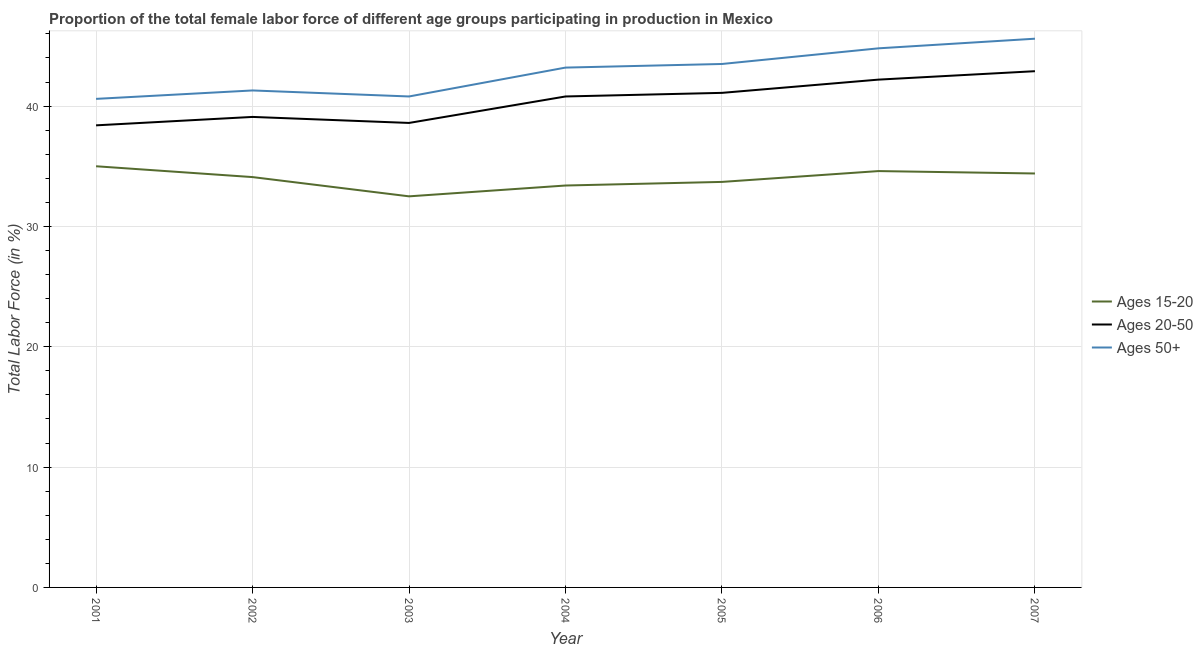What is the percentage of female labor force above age 50 in 2003?
Provide a short and direct response. 40.8. Across all years, what is the minimum percentage of female labor force above age 50?
Offer a very short reply. 40.6. What is the total percentage of female labor force within the age group 20-50 in the graph?
Your answer should be very brief. 283.1. What is the difference between the percentage of female labor force within the age group 15-20 in 2004 and that in 2007?
Keep it short and to the point. -1. What is the difference between the percentage of female labor force within the age group 15-20 in 2007 and the percentage of female labor force within the age group 20-50 in 2004?
Provide a short and direct response. -6.4. What is the average percentage of female labor force above age 50 per year?
Offer a terse response. 42.83. In the year 2001, what is the difference between the percentage of female labor force within the age group 20-50 and percentage of female labor force above age 50?
Offer a very short reply. -2.2. In how many years, is the percentage of female labor force within the age group 15-20 greater than 4 %?
Give a very brief answer. 7. What is the ratio of the percentage of female labor force above age 50 in 2006 to that in 2007?
Give a very brief answer. 0.98. Is the difference between the percentage of female labor force within the age group 20-50 in 2003 and 2006 greater than the difference between the percentage of female labor force within the age group 15-20 in 2003 and 2006?
Your answer should be very brief. No. What is the difference between the highest and the second highest percentage of female labor force above age 50?
Your answer should be very brief. 0.8. In how many years, is the percentage of female labor force within the age group 15-20 greater than the average percentage of female labor force within the age group 15-20 taken over all years?
Offer a very short reply. 4. Is the sum of the percentage of female labor force above age 50 in 2005 and 2006 greater than the maximum percentage of female labor force within the age group 20-50 across all years?
Offer a very short reply. Yes. Is it the case that in every year, the sum of the percentage of female labor force within the age group 15-20 and percentage of female labor force within the age group 20-50 is greater than the percentage of female labor force above age 50?
Make the answer very short. Yes. Does the percentage of female labor force within the age group 15-20 monotonically increase over the years?
Provide a succinct answer. No. How many years are there in the graph?
Give a very brief answer. 7. Are the values on the major ticks of Y-axis written in scientific E-notation?
Your answer should be compact. No. Where does the legend appear in the graph?
Ensure brevity in your answer.  Center right. What is the title of the graph?
Keep it short and to the point. Proportion of the total female labor force of different age groups participating in production in Mexico. Does "Other sectors" appear as one of the legend labels in the graph?
Offer a terse response. No. What is the Total Labor Force (in %) in Ages 15-20 in 2001?
Provide a short and direct response. 35. What is the Total Labor Force (in %) of Ages 20-50 in 2001?
Make the answer very short. 38.4. What is the Total Labor Force (in %) in Ages 50+ in 2001?
Provide a succinct answer. 40.6. What is the Total Labor Force (in %) in Ages 15-20 in 2002?
Ensure brevity in your answer.  34.1. What is the Total Labor Force (in %) of Ages 20-50 in 2002?
Keep it short and to the point. 39.1. What is the Total Labor Force (in %) of Ages 50+ in 2002?
Ensure brevity in your answer.  41.3. What is the Total Labor Force (in %) of Ages 15-20 in 2003?
Give a very brief answer. 32.5. What is the Total Labor Force (in %) in Ages 20-50 in 2003?
Provide a succinct answer. 38.6. What is the Total Labor Force (in %) of Ages 50+ in 2003?
Your answer should be compact. 40.8. What is the Total Labor Force (in %) of Ages 15-20 in 2004?
Ensure brevity in your answer.  33.4. What is the Total Labor Force (in %) in Ages 20-50 in 2004?
Offer a terse response. 40.8. What is the Total Labor Force (in %) in Ages 50+ in 2004?
Give a very brief answer. 43.2. What is the Total Labor Force (in %) in Ages 15-20 in 2005?
Your answer should be compact. 33.7. What is the Total Labor Force (in %) of Ages 20-50 in 2005?
Provide a short and direct response. 41.1. What is the Total Labor Force (in %) of Ages 50+ in 2005?
Your answer should be very brief. 43.5. What is the Total Labor Force (in %) of Ages 15-20 in 2006?
Ensure brevity in your answer.  34.6. What is the Total Labor Force (in %) in Ages 20-50 in 2006?
Provide a succinct answer. 42.2. What is the Total Labor Force (in %) in Ages 50+ in 2006?
Give a very brief answer. 44.8. What is the Total Labor Force (in %) of Ages 15-20 in 2007?
Provide a short and direct response. 34.4. What is the Total Labor Force (in %) of Ages 20-50 in 2007?
Your response must be concise. 42.9. What is the Total Labor Force (in %) in Ages 50+ in 2007?
Ensure brevity in your answer.  45.6. Across all years, what is the maximum Total Labor Force (in %) of Ages 15-20?
Keep it short and to the point. 35. Across all years, what is the maximum Total Labor Force (in %) in Ages 20-50?
Your answer should be compact. 42.9. Across all years, what is the maximum Total Labor Force (in %) in Ages 50+?
Offer a terse response. 45.6. Across all years, what is the minimum Total Labor Force (in %) of Ages 15-20?
Keep it short and to the point. 32.5. Across all years, what is the minimum Total Labor Force (in %) of Ages 20-50?
Provide a short and direct response. 38.4. Across all years, what is the minimum Total Labor Force (in %) of Ages 50+?
Your response must be concise. 40.6. What is the total Total Labor Force (in %) of Ages 15-20 in the graph?
Your response must be concise. 237.7. What is the total Total Labor Force (in %) of Ages 20-50 in the graph?
Your answer should be very brief. 283.1. What is the total Total Labor Force (in %) in Ages 50+ in the graph?
Keep it short and to the point. 299.8. What is the difference between the Total Labor Force (in %) in Ages 20-50 in 2001 and that in 2002?
Provide a succinct answer. -0.7. What is the difference between the Total Labor Force (in %) of Ages 50+ in 2001 and that in 2002?
Offer a terse response. -0.7. What is the difference between the Total Labor Force (in %) in Ages 20-50 in 2001 and that in 2003?
Offer a very short reply. -0.2. What is the difference between the Total Labor Force (in %) in Ages 15-20 in 2001 and that in 2004?
Give a very brief answer. 1.6. What is the difference between the Total Labor Force (in %) in Ages 20-50 in 2001 and that in 2004?
Provide a short and direct response. -2.4. What is the difference between the Total Labor Force (in %) in Ages 50+ in 2001 and that in 2004?
Make the answer very short. -2.6. What is the difference between the Total Labor Force (in %) in Ages 15-20 in 2001 and that in 2005?
Your answer should be compact. 1.3. What is the difference between the Total Labor Force (in %) in Ages 50+ in 2001 and that in 2007?
Ensure brevity in your answer.  -5. What is the difference between the Total Labor Force (in %) of Ages 50+ in 2002 and that in 2004?
Give a very brief answer. -1.9. What is the difference between the Total Labor Force (in %) of Ages 20-50 in 2002 and that in 2005?
Give a very brief answer. -2. What is the difference between the Total Labor Force (in %) of Ages 50+ in 2002 and that in 2005?
Your response must be concise. -2.2. What is the difference between the Total Labor Force (in %) of Ages 50+ in 2002 and that in 2007?
Offer a terse response. -4.3. What is the difference between the Total Labor Force (in %) in Ages 50+ in 2003 and that in 2004?
Your answer should be compact. -2.4. What is the difference between the Total Labor Force (in %) of Ages 15-20 in 2003 and that in 2005?
Offer a terse response. -1.2. What is the difference between the Total Labor Force (in %) of Ages 20-50 in 2003 and that in 2006?
Keep it short and to the point. -3.6. What is the difference between the Total Labor Force (in %) of Ages 50+ in 2004 and that in 2005?
Provide a short and direct response. -0.3. What is the difference between the Total Labor Force (in %) in Ages 15-20 in 2004 and that in 2006?
Offer a terse response. -1.2. What is the difference between the Total Labor Force (in %) of Ages 50+ in 2004 and that in 2007?
Give a very brief answer. -2.4. What is the difference between the Total Labor Force (in %) of Ages 50+ in 2005 and that in 2006?
Provide a short and direct response. -1.3. What is the difference between the Total Labor Force (in %) in Ages 20-50 in 2005 and that in 2007?
Offer a very short reply. -1.8. What is the difference between the Total Labor Force (in %) in Ages 50+ in 2005 and that in 2007?
Provide a short and direct response. -2.1. What is the difference between the Total Labor Force (in %) in Ages 20-50 in 2006 and that in 2007?
Provide a succinct answer. -0.7. What is the difference between the Total Labor Force (in %) of Ages 15-20 in 2001 and the Total Labor Force (in %) of Ages 50+ in 2002?
Provide a succinct answer. -6.3. What is the difference between the Total Labor Force (in %) of Ages 20-50 in 2001 and the Total Labor Force (in %) of Ages 50+ in 2003?
Keep it short and to the point. -2.4. What is the difference between the Total Labor Force (in %) of Ages 15-20 in 2001 and the Total Labor Force (in %) of Ages 20-50 in 2004?
Your response must be concise. -5.8. What is the difference between the Total Labor Force (in %) of Ages 20-50 in 2001 and the Total Labor Force (in %) of Ages 50+ in 2004?
Give a very brief answer. -4.8. What is the difference between the Total Labor Force (in %) in Ages 15-20 in 2001 and the Total Labor Force (in %) in Ages 20-50 in 2005?
Keep it short and to the point. -6.1. What is the difference between the Total Labor Force (in %) in Ages 20-50 in 2001 and the Total Labor Force (in %) in Ages 50+ in 2005?
Your answer should be very brief. -5.1. What is the difference between the Total Labor Force (in %) of Ages 15-20 in 2001 and the Total Labor Force (in %) of Ages 20-50 in 2006?
Offer a very short reply. -7.2. What is the difference between the Total Labor Force (in %) in Ages 15-20 in 2001 and the Total Labor Force (in %) in Ages 50+ in 2006?
Your answer should be very brief. -9.8. What is the difference between the Total Labor Force (in %) in Ages 20-50 in 2001 and the Total Labor Force (in %) in Ages 50+ in 2006?
Provide a succinct answer. -6.4. What is the difference between the Total Labor Force (in %) in Ages 15-20 in 2001 and the Total Labor Force (in %) in Ages 50+ in 2007?
Your answer should be very brief. -10.6. What is the difference between the Total Labor Force (in %) of Ages 15-20 in 2002 and the Total Labor Force (in %) of Ages 50+ in 2003?
Offer a very short reply. -6.7. What is the difference between the Total Labor Force (in %) in Ages 15-20 in 2002 and the Total Labor Force (in %) in Ages 20-50 in 2004?
Your answer should be compact. -6.7. What is the difference between the Total Labor Force (in %) in Ages 15-20 in 2002 and the Total Labor Force (in %) in Ages 20-50 in 2005?
Your answer should be compact. -7. What is the difference between the Total Labor Force (in %) in Ages 20-50 in 2002 and the Total Labor Force (in %) in Ages 50+ in 2005?
Your response must be concise. -4.4. What is the difference between the Total Labor Force (in %) of Ages 15-20 in 2002 and the Total Labor Force (in %) of Ages 50+ in 2006?
Your answer should be very brief. -10.7. What is the difference between the Total Labor Force (in %) of Ages 15-20 in 2003 and the Total Labor Force (in %) of Ages 20-50 in 2004?
Offer a terse response. -8.3. What is the difference between the Total Labor Force (in %) of Ages 15-20 in 2003 and the Total Labor Force (in %) of Ages 50+ in 2005?
Offer a very short reply. -11. What is the difference between the Total Labor Force (in %) of Ages 15-20 in 2003 and the Total Labor Force (in %) of Ages 50+ in 2006?
Your response must be concise. -12.3. What is the difference between the Total Labor Force (in %) in Ages 15-20 in 2003 and the Total Labor Force (in %) in Ages 20-50 in 2007?
Your answer should be compact. -10.4. What is the difference between the Total Labor Force (in %) in Ages 15-20 in 2003 and the Total Labor Force (in %) in Ages 50+ in 2007?
Give a very brief answer. -13.1. What is the difference between the Total Labor Force (in %) of Ages 20-50 in 2003 and the Total Labor Force (in %) of Ages 50+ in 2007?
Your response must be concise. -7. What is the difference between the Total Labor Force (in %) of Ages 15-20 in 2004 and the Total Labor Force (in %) of Ages 20-50 in 2005?
Keep it short and to the point. -7.7. What is the difference between the Total Labor Force (in %) of Ages 15-20 in 2004 and the Total Labor Force (in %) of Ages 20-50 in 2006?
Keep it short and to the point. -8.8. What is the difference between the Total Labor Force (in %) of Ages 20-50 in 2004 and the Total Labor Force (in %) of Ages 50+ in 2006?
Offer a terse response. -4. What is the difference between the Total Labor Force (in %) of Ages 15-20 in 2004 and the Total Labor Force (in %) of Ages 50+ in 2007?
Give a very brief answer. -12.2. What is the difference between the Total Labor Force (in %) of Ages 20-50 in 2004 and the Total Labor Force (in %) of Ages 50+ in 2007?
Provide a succinct answer. -4.8. What is the difference between the Total Labor Force (in %) in Ages 15-20 in 2005 and the Total Labor Force (in %) in Ages 50+ in 2006?
Give a very brief answer. -11.1. What is the difference between the Total Labor Force (in %) of Ages 20-50 in 2005 and the Total Labor Force (in %) of Ages 50+ in 2006?
Keep it short and to the point. -3.7. What is the difference between the Total Labor Force (in %) in Ages 15-20 in 2005 and the Total Labor Force (in %) in Ages 20-50 in 2007?
Your answer should be very brief. -9.2. What is the difference between the Total Labor Force (in %) in Ages 20-50 in 2005 and the Total Labor Force (in %) in Ages 50+ in 2007?
Make the answer very short. -4.5. What is the difference between the Total Labor Force (in %) of Ages 15-20 in 2006 and the Total Labor Force (in %) of Ages 20-50 in 2007?
Make the answer very short. -8.3. What is the difference between the Total Labor Force (in %) of Ages 15-20 in 2006 and the Total Labor Force (in %) of Ages 50+ in 2007?
Your response must be concise. -11. What is the average Total Labor Force (in %) of Ages 15-20 per year?
Your answer should be compact. 33.96. What is the average Total Labor Force (in %) in Ages 20-50 per year?
Give a very brief answer. 40.44. What is the average Total Labor Force (in %) of Ages 50+ per year?
Provide a succinct answer. 42.83. In the year 2001, what is the difference between the Total Labor Force (in %) in Ages 15-20 and Total Labor Force (in %) in Ages 20-50?
Ensure brevity in your answer.  -3.4. In the year 2001, what is the difference between the Total Labor Force (in %) of Ages 20-50 and Total Labor Force (in %) of Ages 50+?
Keep it short and to the point. -2.2. In the year 2002, what is the difference between the Total Labor Force (in %) of Ages 15-20 and Total Labor Force (in %) of Ages 20-50?
Give a very brief answer. -5. In the year 2002, what is the difference between the Total Labor Force (in %) in Ages 15-20 and Total Labor Force (in %) in Ages 50+?
Ensure brevity in your answer.  -7.2. In the year 2002, what is the difference between the Total Labor Force (in %) in Ages 20-50 and Total Labor Force (in %) in Ages 50+?
Your answer should be compact. -2.2. In the year 2003, what is the difference between the Total Labor Force (in %) of Ages 15-20 and Total Labor Force (in %) of Ages 20-50?
Your answer should be very brief. -6.1. In the year 2003, what is the difference between the Total Labor Force (in %) of Ages 20-50 and Total Labor Force (in %) of Ages 50+?
Your response must be concise. -2.2. In the year 2004, what is the difference between the Total Labor Force (in %) of Ages 15-20 and Total Labor Force (in %) of Ages 50+?
Provide a short and direct response. -9.8. In the year 2004, what is the difference between the Total Labor Force (in %) in Ages 20-50 and Total Labor Force (in %) in Ages 50+?
Your answer should be compact. -2.4. In the year 2005, what is the difference between the Total Labor Force (in %) in Ages 15-20 and Total Labor Force (in %) in Ages 20-50?
Your response must be concise. -7.4. In the year 2005, what is the difference between the Total Labor Force (in %) in Ages 15-20 and Total Labor Force (in %) in Ages 50+?
Make the answer very short. -9.8. In the year 2005, what is the difference between the Total Labor Force (in %) of Ages 20-50 and Total Labor Force (in %) of Ages 50+?
Offer a terse response. -2.4. In the year 2006, what is the difference between the Total Labor Force (in %) of Ages 15-20 and Total Labor Force (in %) of Ages 50+?
Ensure brevity in your answer.  -10.2. In the year 2007, what is the difference between the Total Labor Force (in %) in Ages 15-20 and Total Labor Force (in %) in Ages 20-50?
Give a very brief answer. -8.5. In the year 2007, what is the difference between the Total Labor Force (in %) of Ages 20-50 and Total Labor Force (in %) of Ages 50+?
Keep it short and to the point. -2.7. What is the ratio of the Total Labor Force (in %) of Ages 15-20 in 2001 to that in 2002?
Provide a succinct answer. 1.03. What is the ratio of the Total Labor Force (in %) in Ages 20-50 in 2001 to that in 2002?
Give a very brief answer. 0.98. What is the ratio of the Total Labor Force (in %) of Ages 50+ in 2001 to that in 2002?
Make the answer very short. 0.98. What is the ratio of the Total Labor Force (in %) in Ages 20-50 in 2001 to that in 2003?
Your answer should be very brief. 0.99. What is the ratio of the Total Labor Force (in %) in Ages 15-20 in 2001 to that in 2004?
Offer a terse response. 1.05. What is the ratio of the Total Labor Force (in %) of Ages 50+ in 2001 to that in 2004?
Ensure brevity in your answer.  0.94. What is the ratio of the Total Labor Force (in %) in Ages 15-20 in 2001 to that in 2005?
Offer a very short reply. 1.04. What is the ratio of the Total Labor Force (in %) of Ages 20-50 in 2001 to that in 2005?
Offer a terse response. 0.93. What is the ratio of the Total Labor Force (in %) in Ages 50+ in 2001 to that in 2005?
Your answer should be compact. 0.93. What is the ratio of the Total Labor Force (in %) in Ages 15-20 in 2001 to that in 2006?
Provide a short and direct response. 1.01. What is the ratio of the Total Labor Force (in %) in Ages 20-50 in 2001 to that in 2006?
Your response must be concise. 0.91. What is the ratio of the Total Labor Force (in %) in Ages 50+ in 2001 to that in 2006?
Provide a succinct answer. 0.91. What is the ratio of the Total Labor Force (in %) in Ages 15-20 in 2001 to that in 2007?
Offer a very short reply. 1.02. What is the ratio of the Total Labor Force (in %) of Ages 20-50 in 2001 to that in 2007?
Provide a succinct answer. 0.9. What is the ratio of the Total Labor Force (in %) in Ages 50+ in 2001 to that in 2007?
Offer a very short reply. 0.89. What is the ratio of the Total Labor Force (in %) of Ages 15-20 in 2002 to that in 2003?
Provide a short and direct response. 1.05. What is the ratio of the Total Labor Force (in %) in Ages 50+ in 2002 to that in 2003?
Offer a very short reply. 1.01. What is the ratio of the Total Labor Force (in %) in Ages 15-20 in 2002 to that in 2004?
Your answer should be very brief. 1.02. What is the ratio of the Total Labor Force (in %) in Ages 50+ in 2002 to that in 2004?
Offer a terse response. 0.96. What is the ratio of the Total Labor Force (in %) of Ages 15-20 in 2002 to that in 2005?
Offer a very short reply. 1.01. What is the ratio of the Total Labor Force (in %) in Ages 20-50 in 2002 to that in 2005?
Make the answer very short. 0.95. What is the ratio of the Total Labor Force (in %) of Ages 50+ in 2002 to that in 2005?
Your response must be concise. 0.95. What is the ratio of the Total Labor Force (in %) in Ages 15-20 in 2002 to that in 2006?
Give a very brief answer. 0.99. What is the ratio of the Total Labor Force (in %) of Ages 20-50 in 2002 to that in 2006?
Provide a succinct answer. 0.93. What is the ratio of the Total Labor Force (in %) of Ages 50+ in 2002 to that in 2006?
Make the answer very short. 0.92. What is the ratio of the Total Labor Force (in %) in Ages 15-20 in 2002 to that in 2007?
Your answer should be very brief. 0.99. What is the ratio of the Total Labor Force (in %) of Ages 20-50 in 2002 to that in 2007?
Make the answer very short. 0.91. What is the ratio of the Total Labor Force (in %) of Ages 50+ in 2002 to that in 2007?
Your answer should be compact. 0.91. What is the ratio of the Total Labor Force (in %) in Ages 15-20 in 2003 to that in 2004?
Offer a very short reply. 0.97. What is the ratio of the Total Labor Force (in %) of Ages 20-50 in 2003 to that in 2004?
Provide a short and direct response. 0.95. What is the ratio of the Total Labor Force (in %) in Ages 50+ in 2003 to that in 2004?
Provide a succinct answer. 0.94. What is the ratio of the Total Labor Force (in %) of Ages 15-20 in 2003 to that in 2005?
Your response must be concise. 0.96. What is the ratio of the Total Labor Force (in %) in Ages 20-50 in 2003 to that in 2005?
Offer a terse response. 0.94. What is the ratio of the Total Labor Force (in %) in Ages 50+ in 2003 to that in 2005?
Keep it short and to the point. 0.94. What is the ratio of the Total Labor Force (in %) in Ages 15-20 in 2003 to that in 2006?
Keep it short and to the point. 0.94. What is the ratio of the Total Labor Force (in %) of Ages 20-50 in 2003 to that in 2006?
Offer a very short reply. 0.91. What is the ratio of the Total Labor Force (in %) of Ages 50+ in 2003 to that in 2006?
Offer a terse response. 0.91. What is the ratio of the Total Labor Force (in %) of Ages 15-20 in 2003 to that in 2007?
Your answer should be very brief. 0.94. What is the ratio of the Total Labor Force (in %) of Ages 20-50 in 2003 to that in 2007?
Your answer should be compact. 0.9. What is the ratio of the Total Labor Force (in %) in Ages 50+ in 2003 to that in 2007?
Offer a very short reply. 0.89. What is the ratio of the Total Labor Force (in %) of Ages 20-50 in 2004 to that in 2005?
Keep it short and to the point. 0.99. What is the ratio of the Total Labor Force (in %) in Ages 50+ in 2004 to that in 2005?
Make the answer very short. 0.99. What is the ratio of the Total Labor Force (in %) in Ages 15-20 in 2004 to that in 2006?
Keep it short and to the point. 0.97. What is the ratio of the Total Labor Force (in %) in Ages 20-50 in 2004 to that in 2006?
Your answer should be very brief. 0.97. What is the ratio of the Total Labor Force (in %) in Ages 50+ in 2004 to that in 2006?
Your answer should be very brief. 0.96. What is the ratio of the Total Labor Force (in %) in Ages 15-20 in 2004 to that in 2007?
Make the answer very short. 0.97. What is the ratio of the Total Labor Force (in %) of Ages 20-50 in 2004 to that in 2007?
Keep it short and to the point. 0.95. What is the ratio of the Total Labor Force (in %) of Ages 20-50 in 2005 to that in 2006?
Your answer should be compact. 0.97. What is the ratio of the Total Labor Force (in %) in Ages 15-20 in 2005 to that in 2007?
Provide a short and direct response. 0.98. What is the ratio of the Total Labor Force (in %) of Ages 20-50 in 2005 to that in 2007?
Offer a terse response. 0.96. What is the ratio of the Total Labor Force (in %) in Ages 50+ in 2005 to that in 2007?
Provide a succinct answer. 0.95. What is the ratio of the Total Labor Force (in %) of Ages 15-20 in 2006 to that in 2007?
Offer a terse response. 1.01. What is the ratio of the Total Labor Force (in %) of Ages 20-50 in 2006 to that in 2007?
Offer a terse response. 0.98. What is the ratio of the Total Labor Force (in %) of Ages 50+ in 2006 to that in 2007?
Your answer should be compact. 0.98. What is the difference between the highest and the second highest Total Labor Force (in %) of Ages 15-20?
Your answer should be very brief. 0.4. What is the difference between the highest and the second highest Total Labor Force (in %) in Ages 20-50?
Your response must be concise. 0.7. What is the difference between the highest and the second highest Total Labor Force (in %) in Ages 50+?
Offer a terse response. 0.8. What is the difference between the highest and the lowest Total Labor Force (in %) in Ages 20-50?
Provide a short and direct response. 4.5. 